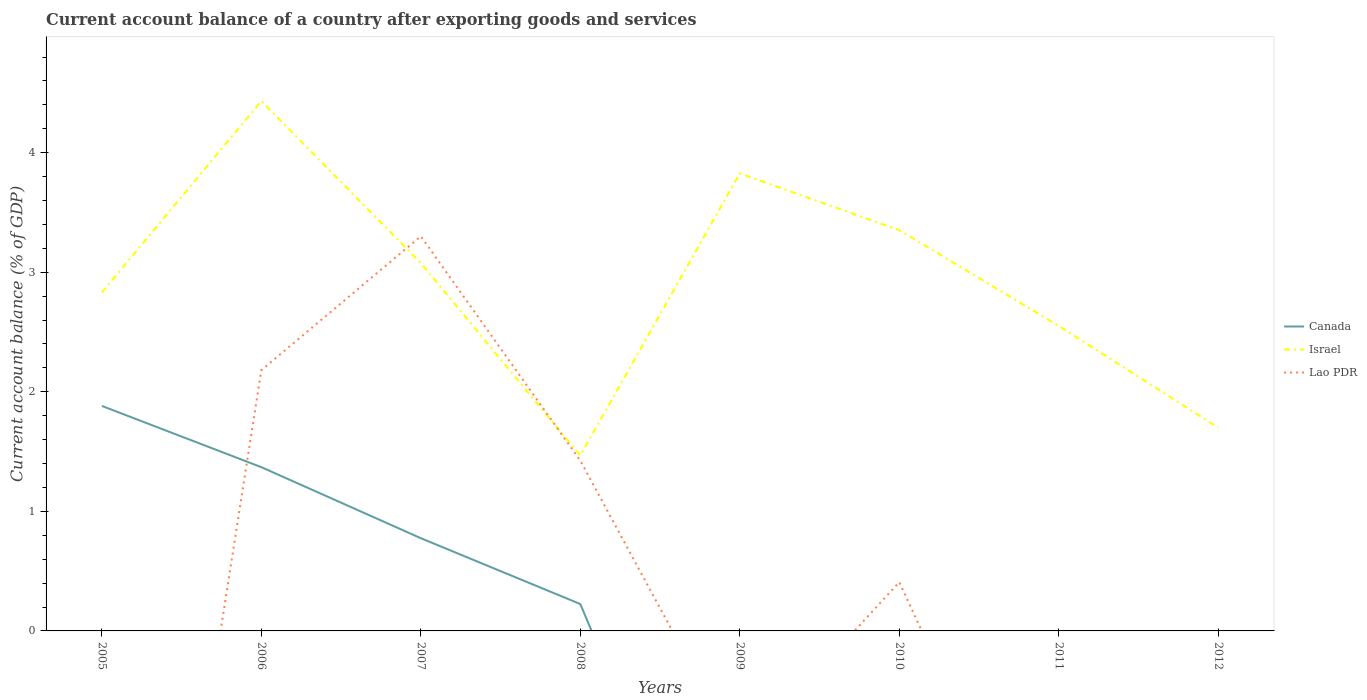How many different coloured lines are there?
Your answer should be very brief. 3. Does the line corresponding to Israel intersect with the line corresponding to Lao PDR?
Your response must be concise. Yes. Across all years, what is the maximum account balance in Israel?
Provide a succinct answer. 1.47. What is the total account balance in Canada in the graph?
Keep it short and to the point. 1.14. What is the difference between the highest and the second highest account balance in Canada?
Your answer should be compact. 1.88. What is the difference between the highest and the lowest account balance in Israel?
Make the answer very short. 4. Is the account balance in Canada strictly greater than the account balance in Lao PDR over the years?
Make the answer very short. No. Are the values on the major ticks of Y-axis written in scientific E-notation?
Offer a terse response. No. Does the graph contain any zero values?
Make the answer very short. Yes. Where does the legend appear in the graph?
Ensure brevity in your answer.  Center right. How many legend labels are there?
Provide a succinct answer. 3. How are the legend labels stacked?
Give a very brief answer. Vertical. What is the title of the graph?
Your answer should be very brief. Current account balance of a country after exporting goods and services. What is the label or title of the X-axis?
Offer a terse response. Years. What is the label or title of the Y-axis?
Your answer should be very brief. Current account balance (% of GDP). What is the Current account balance (% of GDP) of Canada in 2005?
Your answer should be very brief. 1.88. What is the Current account balance (% of GDP) in Israel in 2005?
Ensure brevity in your answer.  2.83. What is the Current account balance (% of GDP) in Canada in 2006?
Keep it short and to the point. 1.37. What is the Current account balance (% of GDP) in Israel in 2006?
Ensure brevity in your answer.  4.43. What is the Current account balance (% of GDP) in Lao PDR in 2006?
Provide a short and direct response. 2.18. What is the Current account balance (% of GDP) in Canada in 2007?
Give a very brief answer. 0.78. What is the Current account balance (% of GDP) of Israel in 2007?
Your response must be concise. 3.08. What is the Current account balance (% of GDP) of Lao PDR in 2007?
Offer a very short reply. 3.3. What is the Current account balance (% of GDP) of Canada in 2008?
Provide a short and direct response. 0.22. What is the Current account balance (% of GDP) in Israel in 2008?
Make the answer very short. 1.47. What is the Current account balance (% of GDP) of Lao PDR in 2008?
Offer a terse response. 1.42. What is the Current account balance (% of GDP) of Canada in 2009?
Offer a terse response. 0. What is the Current account balance (% of GDP) in Israel in 2009?
Your response must be concise. 3.83. What is the Current account balance (% of GDP) of Lao PDR in 2009?
Your response must be concise. 0. What is the Current account balance (% of GDP) in Israel in 2010?
Ensure brevity in your answer.  3.35. What is the Current account balance (% of GDP) in Lao PDR in 2010?
Keep it short and to the point. 0.41. What is the Current account balance (% of GDP) in Israel in 2011?
Your response must be concise. 2.55. What is the Current account balance (% of GDP) in Canada in 2012?
Provide a short and direct response. 0. What is the Current account balance (% of GDP) in Israel in 2012?
Your response must be concise. 1.7. What is the Current account balance (% of GDP) of Lao PDR in 2012?
Give a very brief answer. 0. Across all years, what is the maximum Current account balance (% of GDP) of Canada?
Your response must be concise. 1.88. Across all years, what is the maximum Current account balance (% of GDP) of Israel?
Offer a terse response. 4.43. Across all years, what is the maximum Current account balance (% of GDP) of Lao PDR?
Keep it short and to the point. 3.3. Across all years, what is the minimum Current account balance (% of GDP) of Israel?
Your response must be concise. 1.47. Across all years, what is the minimum Current account balance (% of GDP) in Lao PDR?
Your response must be concise. 0. What is the total Current account balance (% of GDP) in Canada in the graph?
Offer a very short reply. 4.25. What is the total Current account balance (% of GDP) of Israel in the graph?
Offer a very short reply. 23.24. What is the total Current account balance (% of GDP) in Lao PDR in the graph?
Provide a short and direct response. 7.31. What is the difference between the Current account balance (% of GDP) of Canada in 2005 and that in 2006?
Your answer should be compact. 0.51. What is the difference between the Current account balance (% of GDP) of Israel in 2005 and that in 2006?
Provide a short and direct response. -1.6. What is the difference between the Current account balance (% of GDP) in Canada in 2005 and that in 2007?
Keep it short and to the point. 1.11. What is the difference between the Current account balance (% of GDP) of Israel in 2005 and that in 2007?
Provide a succinct answer. -0.25. What is the difference between the Current account balance (% of GDP) in Canada in 2005 and that in 2008?
Ensure brevity in your answer.  1.66. What is the difference between the Current account balance (% of GDP) of Israel in 2005 and that in 2008?
Your answer should be very brief. 1.36. What is the difference between the Current account balance (% of GDP) in Israel in 2005 and that in 2009?
Offer a terse response. -1. What is the difference between the Current account balance (% of GDP) of Israel in 2005 and that in 2010?
Provide a succinct answer. -0.52. What is the difference between the Current account balance (% of GDP) in Israel in 2005 and that in 2011?
Offer a terse response. 0.28. What is the difference between the Current account balance (% of GDP) of Israel in 2005 and that in 2012?
Your answer should be compact. 1.13. What is the difference between the Current account balance (% of GDP) in Canada in 2006 and that in 2007?
Offer a terse response. 0.59. What is the difference between the Current account balance (% of GDP) of Israel in 2006 and that in 2007?
Offer a very short reply. 1.35. What is the difference between the Current account balance (% of GDP) of Lao PDR in 2006 and that in 2007?
Ensure brevity in your answer.  -1.12. What is the difference between the Current account balance (% of GDP) of Canada in 2006 and that in 2008?
Give a very brief answer. 1.14. What is the difference between the Current account balance (% of GDP) of Israel in 2006 and that in 2008?
Offer a terse response. 2.96. What is the difference between the Current account balance (% of GDP) in Lao PDR in 2006 and that in 2008?
Your response must be concise. 0.76. What is the difference between the Current account balance (% of GDP) of Israel in 2006 and that in 2009?
Provide a succinct answer. 0.61. What is the difference between the Current account balance (% of GDP) in Israel in 2006 and that in 2010?
Your answer should be very brief. 1.08. What is the difference between the Current account balance (% of GDP) of Lao PDR in 2006 and that in 2010?
Give a very brief answer. 1.77. What is the difference between the Current account balance (% of GDP) of Israel in 2006 and that in 2011?
Give a very brief answer. 1.88. What is the difference between the Current account balance (% of GDP) of Israel in 2006 and that in 2012?
Your answer should be compact. 2.73. What is the difference between the Current account balance (% of GDP) in Canada in 2007 and that in 2008?
Your answer should be very brief. 0.55. What is the difference between the Current account balance (% of GDP) of Israel in 2007 and that in 2008?
Give a very brief answer. 1.61. What is the difference between the Current account balance (% of GDP) in Lao PDR in 2007 and that in 2008?
Provide a short and direct response. 1.88. What is the difference between the Current account balance (% of GDP) of Israel in 2007 and that in 2009?
Provide a short and direct response. -0.75. What is the difference between the Current account balance (% of GDP) in Israel in 2007 and that in 2010?
Offer a terse response. -0.27. What is the difference between the Current account balance (% of GDP) of Lao PDR in 2007 and that in 2010?
Offer a very short reply. 2.89. What is the difference between the Current account balance (% of GDP) in Israel in 2007 and that in 2011?
Your response must be concise. 0.53. What is the difference between the Current account balance (% of GDP) in Israel in 2007 and that in 2012?
Keep it short and to the point. 1.38. What is the difference between the Current account balance (% of GDP) of Israel in 2008 and that in 2009?
Offer a very short reply. -2.36. What is the difference between the Current account balance (% of GDP) in Israel in 2008 and that in 2010?
Offer a very short reply. -1.88. What is the difference between the Current account balance (% of GDP) in Lao PDR in 2008 and that in 2010?
Your response must be concise. 1.02. What is the difference between the Current account balance (% of GDP) of Israel in 2008 and that in 2011?
Provide a succinct answer. -1.08. What is the difference between the Current account balance (% of GDP) in Israel in 2008 and that in 2012?
Give a very brief answer. -0.23. What is the difference between the Current account balance (% of GDP) of Israel in 2009 and that in 2010?
Offer a very short reply. 0.48. What is the difference between the Current account balance (% of GDP) in Israel in 2009 and that in 2011?
Provide a short and direct response. 1.28. What is the difference between the Current account balance (% of GDP) in Israel in 2009 and that in 2012?
Keep it short and to the point. 2.13. What is the difference between the Current account balance (% of GDP) in Israel in 2010 and that in 2011?
Give a very brief answer. 0.8. What is the difference between the Current account balance (% of GDP) of Israel in 2010 and that in 2012?
Your response must be concise. 1.65. What is the difference between the Current account balance (% of GDP) in Israel in 2011 and that in 2012?
Offer a terse response. 0.85. What is the difference between the Current account balance (% of GDP) of Canada in 2005 and the Current account balance (% of GDP) of Israel in 2006?
Your answer should be compact. -2.55. What is the difference between the Current account balance (% of GDP) in Canada in 2005 and the Current account balance (% of GDP) in Lao PDR in 2006?
Offer a very short reply. -0.3. What is the difference between the Current account balance (% of GDP) of Israel in 2005 and the Current account balance (% of GDP) of Lao PDR in 2006?
Offer a very short reply. 0.65. What is the difference between the Current account balance (% of GDP) of Canada in 2005 and the Current account balance (% of GDP) of Israel in 2007?
Give a very brief answer. -1.2. What is the difference between the Current account balance (% of GDP) of Canada in 2005 and the Current account balance (% of GDP) of Lao PDR in 2007?
Your response must be concise. -1.42. What is the difference between the Current account balance (% of GDP) in Israel in 2005 and the Current account balance (% of GDP) in Lao PDR in 2007?
Provide a succinct answer. -0.47. What is the difference between the Current account balance (% of GDP) in Canada in 2005 and the Current account balance (% of GDP) in Israel in 2008?
Your answer should be very brief. 0.41. What is the difference between the Current account balance (% of GDP) of Canada in 2005 and the Current account balance (% of GDP) of Lao PDR in 2008?
Offer a terse response. 0.46. What is the difference between the Current account balance (% of GDP) in Israel in 2005 and the Current account balance (% of GDP) in Lao PDR in 2008?
Your answer should be very brief. 1.41. What is the difference between the Current account balance (% of GDP) in Canada in 2005 and the Current account balance (% of GDP) in Israel in 2009?
Your answer should be very brief. -1.95. What is the difference between the Current account balance (% of GDP) of Canada in 2005 and the Current account balance (% of GDP) of Israel in 2010?
Keep it short and to the point. -1.47. What is the difference between the Current account balance (% of GDP) in Canada in 2005 and the Current account balance (% of GDP) in Lao PDR in 2010?
Make the answer very short. 1.47. What is the difference between the Current account balance (% of GDP) in Israel in 2005 and the Current account balance (% of GDP) in Lao PDR in 2010?
Your answer should be very brief. 2.42. What is the difference between the Current account balance (% of GDP) of Canada in 2005 and the Current account balance (% of GDP) of Israel in 2011?
Offer a terse response. -0.67. What is the difference between the Current account balance (% of GDP) of Canada in 2005 and the Current account balance (% of GDP) of Israel in 2012?
Offer a very short reply. 0.18. What is the difference between the Current account balance (% of GDP) in Canada in 2006 and the Current account balance (% of GDP) in Israel in 2007?
Provide a succinct answer. -1.71. What is the difference between the Current account balance (% of GDP) in Canada in 2006 and the Current account balance (% of GDP) in Lao PDR in 2007?
Keep it short and to the point. -1.93. What is the difference between the Current account balance (% of GDP) of Israel in 2006 and the Current account balance (% of GDP) of Lao PDR in 2007?
Make the answer very short. 1.13. What is the difference between the Current account balance (% of GDP) in Canada in 2006 and the Current account balance (% of GDP) in Israel in 2008?
Make the answer very short. -0.1. What is the difference between the Current account balance (% of GDP) of Canada in 2006 and the Current account balance (% of GDP) of Lao PDR in 2008?
Ensure brevity in your answer.  -0.05. What is the difference between the Current account balance (% of GDP) of Israel in 2006 and the Current account balance (% of GDP) of Lao PDR in 2008?
Offer a terse response. 3.01. What is the difference between the Current account balance (% of GDP) of Canada in 2006 and the Current account balance (% of GDP) of Israel in 2009?
Give a very brief answer. -2.46. What is the difference between the Current account balance (% of GDP) in Canada in 2006 and the Current account balance (% of GDP) in Israel in 2010?
Keep it short and to the point. -1.98. What is the difference between the Current account balance (% of GDP) of Canada in 2006 and the Current account balance (% of GDP) of Lao PDR in 2010?
Provide a short and direct response. 0.96. What is the difference between the Current account balance (% of GDP) of Israel in 2006 and the Current account balance (% of GDP) of Lao PDR in 2010?
Offer a terse response. 4.02. What is the difference between the Current account balance (% of GDP) in Canada in 2006 and the Current account balance (% of GDP) in Israel in 2011?
Offer a terse response. -1.18. What is the difference between the Current account balance (% of GDP) in Canada in 2006 and the Current account balance (% of GDP) in Israel in 2012?
Offer a very short reply. -0.33. What is the difference between the Current account balance (% of GDP) of Canada in 2007 and the Current account balance (% of GDP) of Israel in 2008?
Your answer should be compact. -0.69. What is the difference between the Current account balance (% of GDP) in Canada in 2007 and the Current account balance (% of GDP) in Lao PDR in 2008?
Your response must be concise. -0.65. What is the difference between the Current account balance (% of GDP) of Israel in 2007 and the Current account balance (% of GDP) of Lao PDR in 2008?
Your answer should be very brief. 1.65. What is the difference between the Current account balance (% of GDP) of Canada in 2007 and the Current account balance (% of GDP) of Israel in 2009?
Make the answer very short. -3.05. What is the difference between the Current account balance (% of GDP) of Canada in 2007 and the Current account balance (% of GDP) of Israel in 2010?
Offer a very short reply. -2.58. What is the difference between the Current account balance (% of GDP) of Canada in 2007 and the Current account balance (% of GDP) of Lao PDR in 2010?
Give a very brief answer. 0.37. What is the difference between the Current account balance (% of GDP) in Israel in 2007 and the Current account balance (% of GDP) in Lao PDR in 2010?
Keep it short and to the point. 2.67. What is the difference between the Current account balance (% of GDP) of Canada in 2007 and the Current account balance (% of GDP) of Israel in 2011?
Your answer should be compact. -1.78. What is the difference between the Current account balance (% of GDP) in Canada in 2007 and the Current account balance (% of GDP) in Israel in 2012?
Give a very brief answer. -0.92. What is the difference between the Current account balance (% of GDP) in Canada in 2008 and the Current account balance (% of GDP) in Israel in 2009?
Provide a short and direct response. -3.6. What is the difference between the Current account balance (% of GDP) of Canada in 2008 and the Current account balance (% of GDP) of Israel in 2010?
Your answer should be compact. -3.13. What is the difference between the Current account balance (% of GDP) of Canada in 2008 and the Current account balance (% of GDP) of Lao PDR in 2010?
Offer a terse response. -0.18. What is the difference between the Current account balance (% of GDP) of Israel in 2008 and the Current account balance (% of GDP) of Lao PDR in 2010?
Make the answer very short. 1.06. What is the difference between the Current account balance (% of GDP) of Canada in 2008 and the Current account balance (% of GDP) of Israel in 2011?
Your response must be concise. -2.33. What is the difference between the Current account balance (% of GDP) of Canada in 2008 and the Current account balance (% of GDP) of Israel in 2012?
Offer a terse response. -1.48. What is the difference between the Current account balance (% of GDP) of Israel in 2009 and the Current account balance (% of GDP) of Lao PDR in 2010?
Offer a terse response. 3.42. What is the average Current account balance (% of GDP) of Canada per year?
Offer a terse response. 0.53. What is the average Current account balance (% of GDP) of Israel per year?
Ensure brevity in your answer.  2.9. What is the average Current account balance (% of GDP) of Lao PDR per year?
Ensure brevity in your answer.  0.91. In the year 2005, what is the difference between the Current account balance (% of GDP) of Canada and Current account balance (% of GDP) of Israel?
Provide a short and direct response. -0.95. In the year 2006, what is the difference between the Current account balance (% of GDP) in Canada and Current account balance (% of GDP) in Israel?
Your answer should be compact. -3.06. In the year 2006, what is the difference between the Current account balance (% of GDP) of Canada and Current account balance (% of GDP) of Lao PDR?
Provide a succinct answer. -0.81. In the year 2006, what is the difference between the Current account balance (% of GDP) in Israel and Current account balance (% of GDP) in Lao PDR?
Provide a short and direct response. 2.25. In the year 2007, what is the difference between the Current account balance (% of GDP) in Canada and Current account balance (% of GDP) in Israel?
Make the answer very short. -2.3. In the year 2007, what is the difference between the Current account balance (% of GDP) of Canada and Current account balance (% of GDP) of Lao PDR?
Your answer should be very brief. -2.53. In the year 2007, what is the difference between the Current account balance (% of GDP) in Israel and Current account balance (% of GDP) in Lao PDR?
Provide a succinct answer. -0.22. In the year 2008, what is the difference between the Current account balance (% of GDP) of Canada and Current account balance (% of GDP) of Israel?
Ensure brevity in your answer.  -1.24. In the year 2008, what is the difference between the Current account balance (% of GDP) of Canada and Current account balance (% of GDP) of Lao PDR?
Make the answer very short. -1.2. In the year 2008, what is the difference between the Current account balance (% of GDP) in Israel and Current account balance (% of GDP) in Lao PDR?
Provide a short and direct response. 0.04. In the year 2010, what is the difference between the Current account balance (% of GDP) of Israel and Current account balance (% of GDP) of Lao PDR?
Offer a terse response. 2.94. What is the ratio of the Current account balance (% of GDP) in Canada in 2005 to that in 2006?
Provide a short and direct response. 1.37. What is the ratio of the Current account balance (% of GDP) in Israel in 2005 to that in 2006?
Provide a succinct answer. 0.64. What is the ratio of the Current account balance (% of GDP) of Canada in 2005 to that in 2007?
Provide a short and direct response. 2.43. What is the ratio of the Current account balance (% of GDP) in Israel in 2005 to that in 2007?
Offer a terse response. 0.92. What is the ratio of the Current account balance (% of GDP) in Canada in 2005 to that in 2008?
Your response must be concise. 8.37. What is the ratio of the Current account balance (% of GDP) in Israel in 2005 to that in 2008?
Give a very brief answer. 1.93. What is the ratio of the Current account balance (% of GDP) in Israel in 2005 to that in 2009?
Your response must be concise. 0.74. What is the ratio of the Current account balance (% of GDP) of Israel in 2005 to that in 2010?
Offer a very short reply. 0.84. What is the ratio of the Current account balance (% of GDP) of Israel in 2005 to that in 2011?
Make the answer very short. 1.11. What is the ratio of the Current account balance (% of GDP) in Israel in 2005 to that in 2012?
Provide a short and direct response. 1.67. What is the ratio of the Current account balance (% of GDP) in Canada in 2006 to that in 2007?
Provide a short and direct response. 1.77. What is the ratio of the Current account balance (% of GDP) in Israel in 2006 to that in 2007?
Give a very brief answer. 1.44. What is the ratio of the Current account balance (% of GDP) in Lao PDR in 2006 to that in 2007?
Offer a very short reply. 0.66. What is the ratio of the Current account balance (% of GDP) in Canada in 2006 to that in 2008?
Keep it short and to the point. 6.09. What is the ratio of the Current account balance (% of GDP) in Israel in 2006 to that in 2008?
Your answer should be compact. 3.02. What is the ratio of the Current account balance (% of GDP) in Lao PDR in 2006 to that in 2008?
Offer a terse response. 1.53. What is the ratio of the Current account balance (% of GDP) of Israel in 2006 to that in 2009?
Offer a terse response. 1.16. What is the ratio of the Current account balance (% of GDP) of Israel in 2006 to that in 2010?
Your answer should be compact. 1.32. What is the ratio of the Current account balance (% of GDP) of Lao PDR in 2006 to that in 2010?
Your response must be concise. 5.34. What is the ratio of the Current account balance (% of GDP) of Israel in 2006 to that in 2011?
Make the answer very short. 1.74. What is the ratio of the Current account balance (% of GDP) in Israel in 2006 to that in 2012?
Your response must be concise. 2.61. What is the ratio of the Current account balance (% of GDP) of Canada in 2007 to that in 2008?
Your answer should be compact. 3.45. What is the ratio of the Current account balance (% of GDP) in Israel in 2007 to that in 2008?
Offer a very short reply. 2.1. What is the ratio of the Current account balance (% of GDP) in Lao PDR in 2007 to that in 2008?
Offer a terse response. 2.32. What is the ratio of the Current account balance (% of GDP) of Israel in 2007 to that in 2009?
Your answer should be compact. 0.8. What is the ratio of the Current account balance (% of GDP) of Israel in 2007 to that in 2010?
Give a very brief answer. 0.92. What is the ratio of the Current account balance (% of GDP) in Lao PDR in 2007 to that in 2010?
Your response must be concise. 8.09. What is the ratio of the Current account balance (% of GDP) of Israel in 2007 to that in 2011?
Make the answer very short. 1.21. What is the ratio of the Current account balance (% of GDP) of Israel in 2007 to that in 2012?
Your answer should be very brief. 1.81. What is the ratio of the Current account balance (% of GDP) of Israel in 2008 to that in 2009?
Your answer should be very brief. 0.38. What is the ratio of the Current account balance (% of GDP) in Israel in 2008 to that in 2010?
Offer a very short reply. 0.44. What is the ratio of the Current account balance (% of GDP) of Lao PDR in 2008 to that in 2010?
Give a very brief answer. 3.49. What is the ratio of the Current account balance (% of GDP) of Israel in 2008 to that in 2011?
Offer a very short reply. 0.58. What is the ratio of the Current account balance (% of GDP) in Israel in 2008 to that in 2012?
Your answer should be very brief. 0.86. What is the ratio of the Current account balance (% of GDP) in Israel in 2009 to that in 2010?
Make the answer very short. 1.14. What is the ratio of the Current account balance (% of GDP) in Israel in 2009 to that in 2011?
Ensure brevity in your answer.  1.5. What is the ratio of the Current account balance (% of GDP) of Israel in 2009 to that in 2012?
Keep it short and to the point. 2.25. What is the ratio of the Current account balance (% of GDP) of Israel in 2010 to that in 2011?
Offer a terse response. 1.31. What is the ratio of the Current account balance (% of GDP) in Israel in 2010 to that in 2012?
Offer a very short reply. 1.97. What is the ratio of the Current account balance (% of GDP) in Israel in 2011 to that in 2012?
Provide a short and direct response. 1.5. What is the difference between the highest and the second highest Current account balance (% of GDP) of Canada?
Ensure brevity in your answer.  0.51. What is the difference between the highest and the second highest Current account balance (% of GDP) in Israel?
Provide a short and direct response. 0.61. What is the difference between the highest and the second highest Current account balance (% of GDP) of Lao PDR?
Make the answer very short. 1.12. What is the difference between the highest and the lowest Current account balance (% of GDP) in Canada?
Ensure brevity in your answer.  1.88. What is the difference between the highest and the lowest Current account balance (% of GDP) of Israel?
Your answer should be very brief. 2.96. What is the difference between the highest and the lowest Current account balance (% of GDP) in Lao PDR?
Offer a terse response. 3.3. 